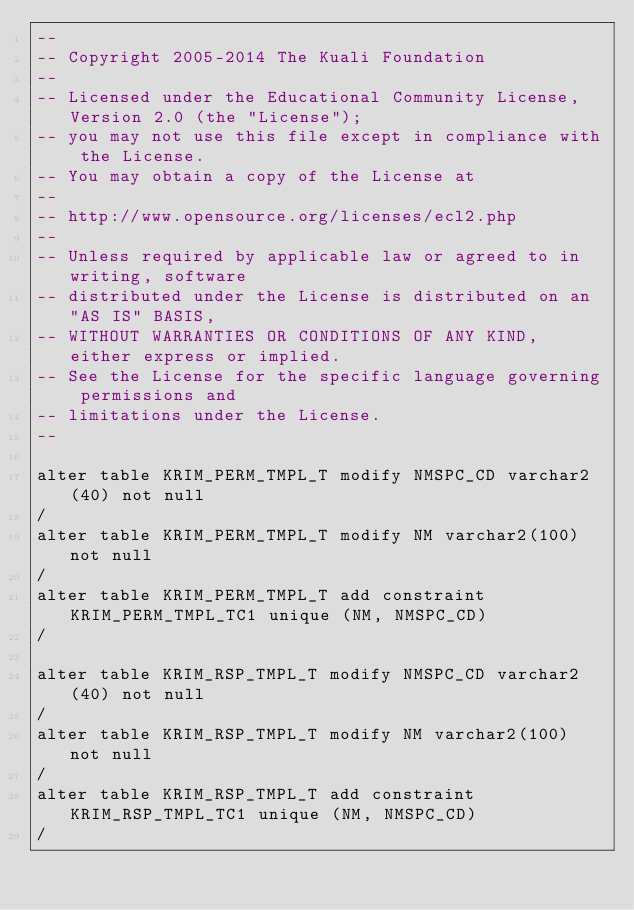Convert code to text. <code><loc_0><loc_0><loc_500><loc_500><_SQL_>--
-- Copyright 2005-2014 The Kuali Foundation
--
-- Licensed under the Educational Community License, Version 2.0 (the "License");
-- you may not use this file except in compliance with the License.
-- You may obtain a copy of the License at
--
-- http://www.opensource.org/licenses/ecl2.php
--
-- Unless required by applicable law or agreed to in writing, software
-- distributed under the License is distributed on an "AS IS" BASIS,
-- WITHOUT WARRANTIES OR CONDITIONS OF ANY KIND, either express or implied.
-- See the License for the specific language governing permissions and
-- limitations under the License.
--

alter table KRIM_PERM_TMPL_T modify NMSPC_CD varchar2(40) not null
/
alter table KRIM_PERM_TMPL_T modify NM varchar2(100) not null
/
alter table KRIM_PERM_TMPL_T add constraint KRIM_PERM_TMPL_TC1 unique (NM, NMSPC_CD)
/

alter table KRIM_RSP_TMPL_T modify NMSPC_CD varchar2(40) not null
/
alter table KRIM_RSP_TMPL_T modify NM varchar2(100) not null
/
alter table KRIM_RSP_TMPL_T add constraint KRIM_RSP_TMPL_TC1 unique (NM, NMSPC_CD)
/</code> 